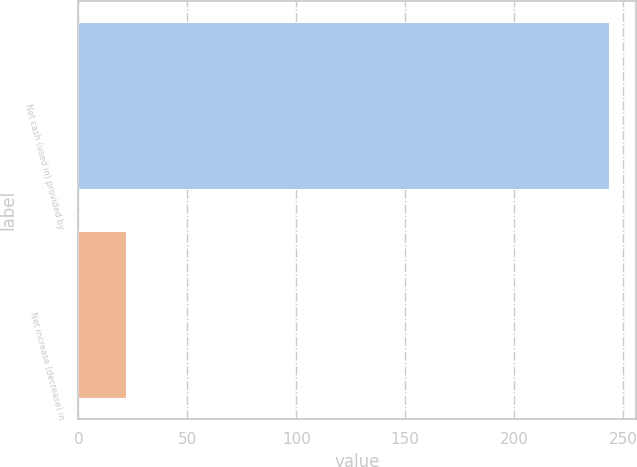Convert chart to OTSL. <chart><loc_0><loc_0><loc_500><loc_500><bar_chart><fcel>Net cash (used in) provided by<fcel>Net increase (decrease) in<nl><fcel>243.8<fcel>21.7<nl></chart> 